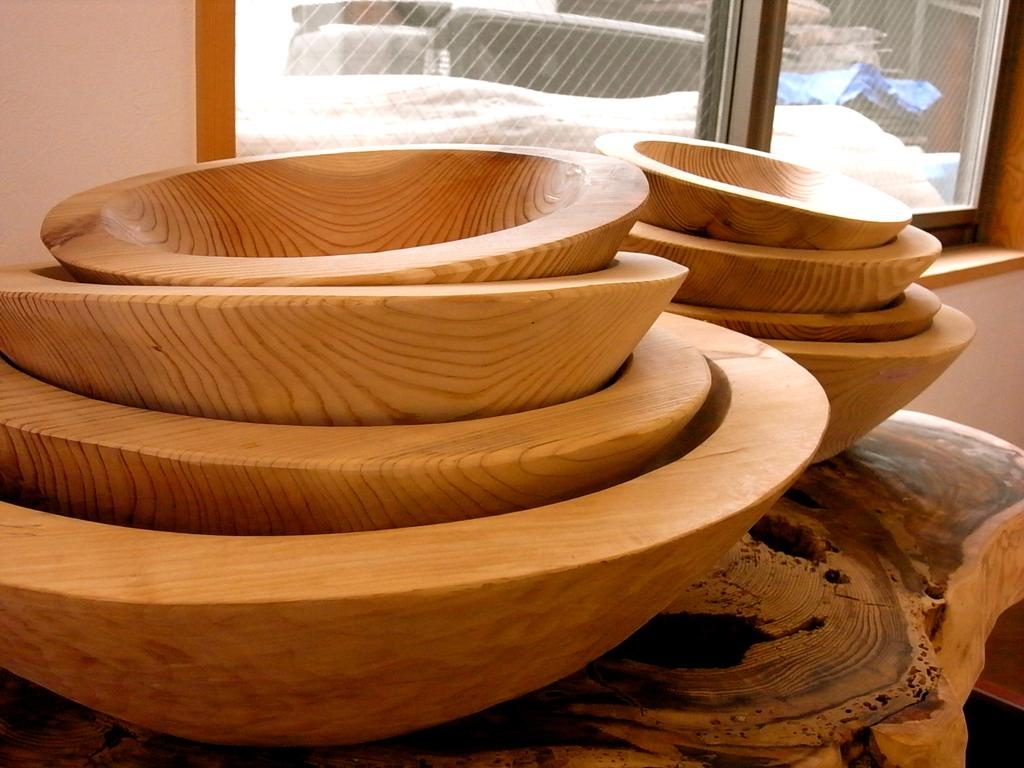What type of bowls are in the front of the image? There are wooden bowls in the front of the image. What can be seen in the background of the image? There is a window in the background of the image. What is visible through the window? There are objects visible through the window. What type of pleasure can be seen in the image? There is no reference to pleasure in the image; it features wooden bowls and a window with objects visible through it. What type of lace is draped over the window in the image? There is no lace present in the image; it features wooden bowls and a window with objects visible through it. 